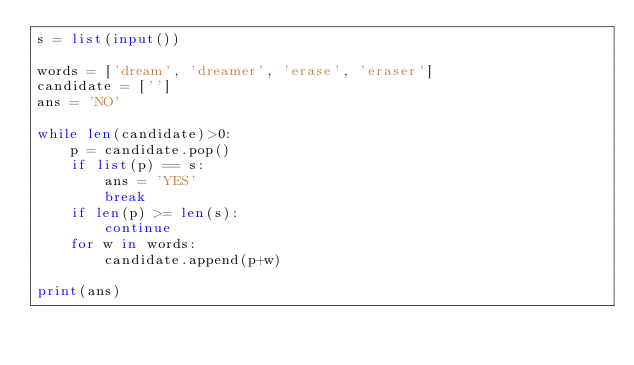<code> <loc_0><loc_0><loc_500><loc_500><_Python_>s = list(input())

words = ['dream', 'dreamer', 'erase', 'eraser']
candidate = ['']
ans = 'NO'

while len(candidate)>0:
    p = candidate.pop()
    if list(p) == s:
        ans = 'YES'
        break
    if len(p) >= len(s):
        continue
    for w in words:
        candidate.append(p+w)

print(ans)
</code> 